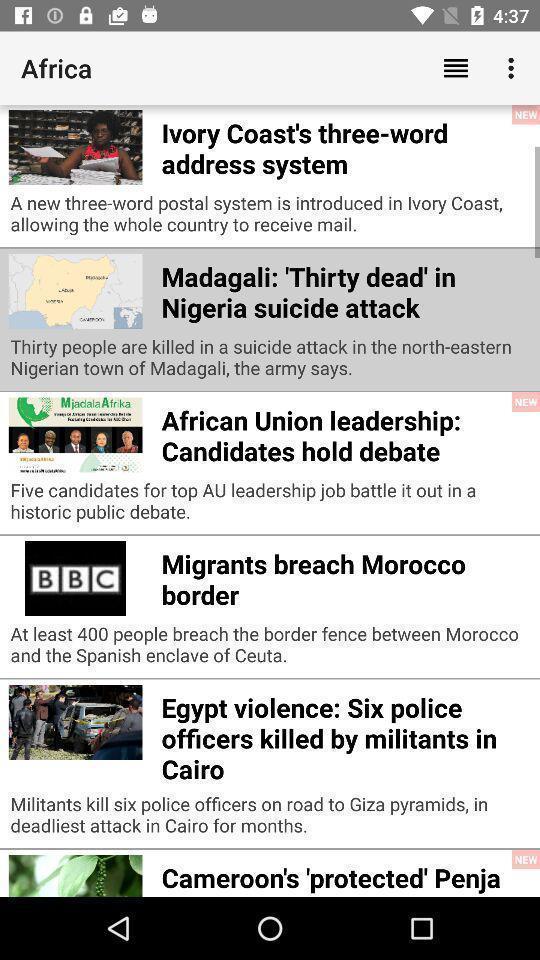Describe the content in this image. Screen shows multiple articles in a news app. 